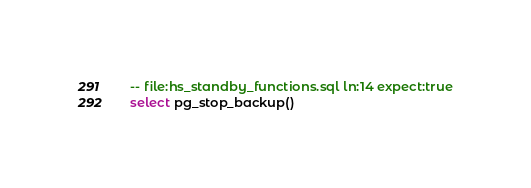Convert code to text. <code><loc_0><loc_0><loc_500><loc_500><_SQL_>-- file:hs_standby_functions.sql ln:14 expect:true
select pg_stop_backup()
</code> 